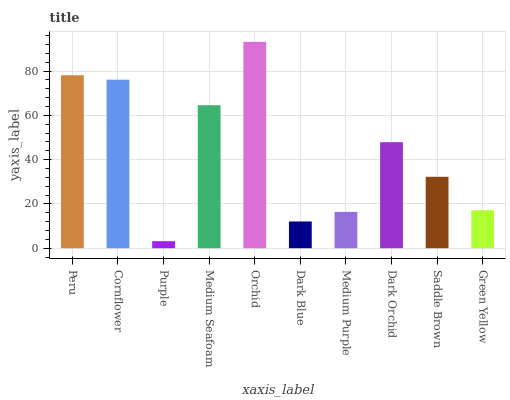Is Purple the minimum?
Answer yes or no. Yes. Is Orchid the maximum?
Answer yes or no. Yes. Is Cornflower the minimum?
Answer yes or no. No. Is Cornflower the maximum?
Answer yes or no. No. Is Peru greater than Cornflower?
Answer yes or no. Yes. Is Cornflower less than Peru?
Answer yes or no. Yes. Is Cornflower greater than Peru?
Answer yes or no. No. Is Peru less than Cornflower?
Answer yes or no. No. Is Dark Orchid the high median?
Answer yes or no. Yes. Is Saddle Brown the low median?
Answer yes or no. Yes. Is Dark Blue the high median?
Answer yes or no. No. Is Medium Purple the low median?
Answer yes or no. No. 